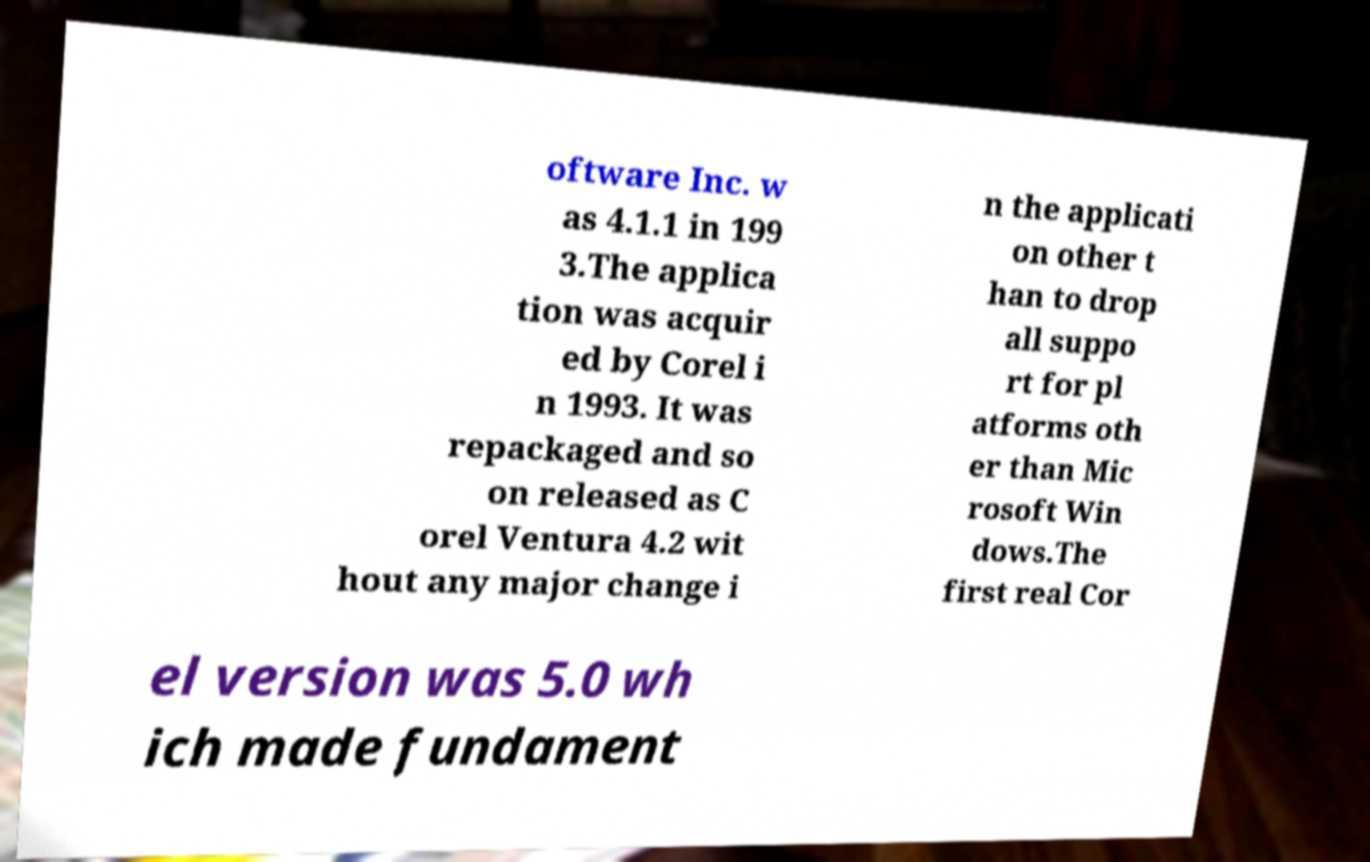Please read and relay the text visible in this image. What does it say? oftware Inc. w as 4.1.1 in 199 3.The applica tion was acquir ed by Corel i n 1993. It was repackaged and so on released as C orel Ventura 4.2 wit hout any major change i n the applicati on other t han to drop all suppo rt for pl atforms oth er than Mic rosoft Win dows.The first real Cor el version was 5.0 wh ich made fundament 